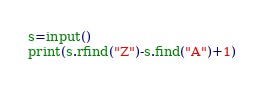Convert code to text. <code><loc_0><loc_0><loc_500><loc_500><_Python_>s=input()
print(s.rfind("Z")-s.find("A")+1)</code> 